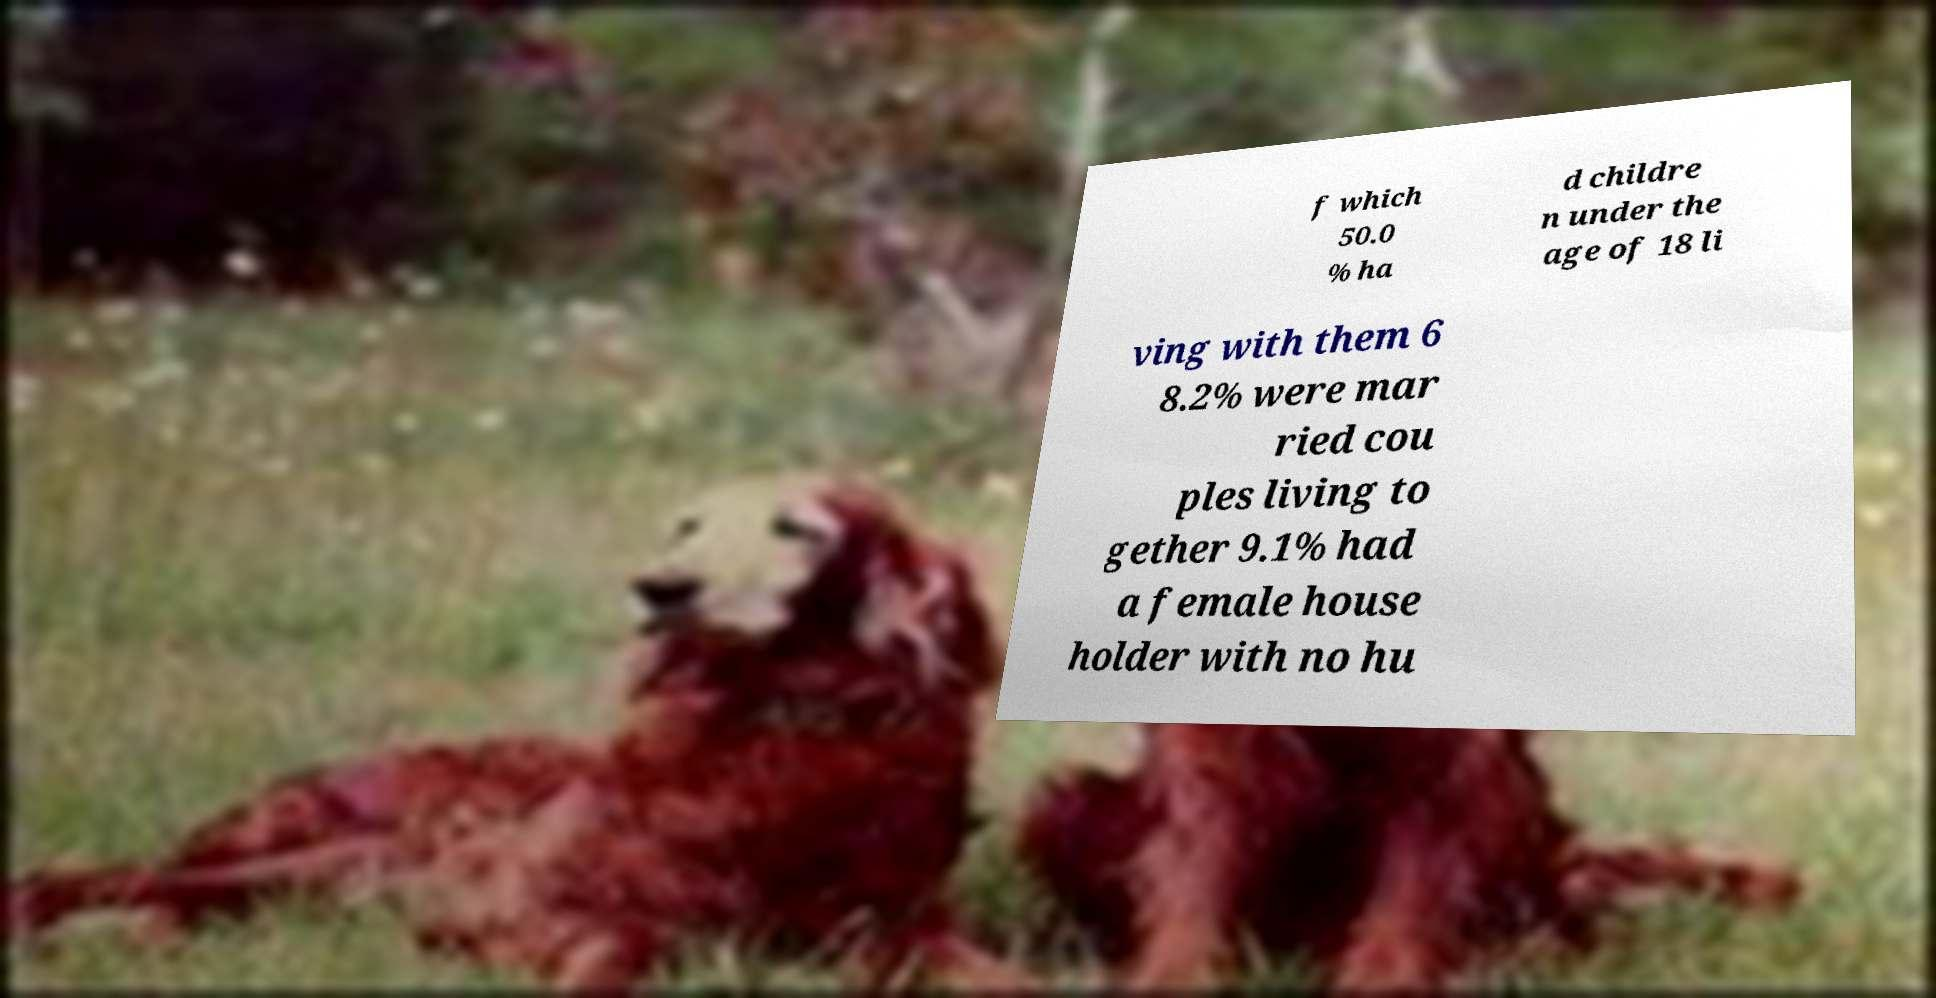For documentation purposes, I need the text within this image transcribed. Could you provide that? f which 50.0 % ha d childre n under the age of 18 li ving with them 6 8.2% were mar ried cou ples living to gether 9.1% had a female house holder with no hu 